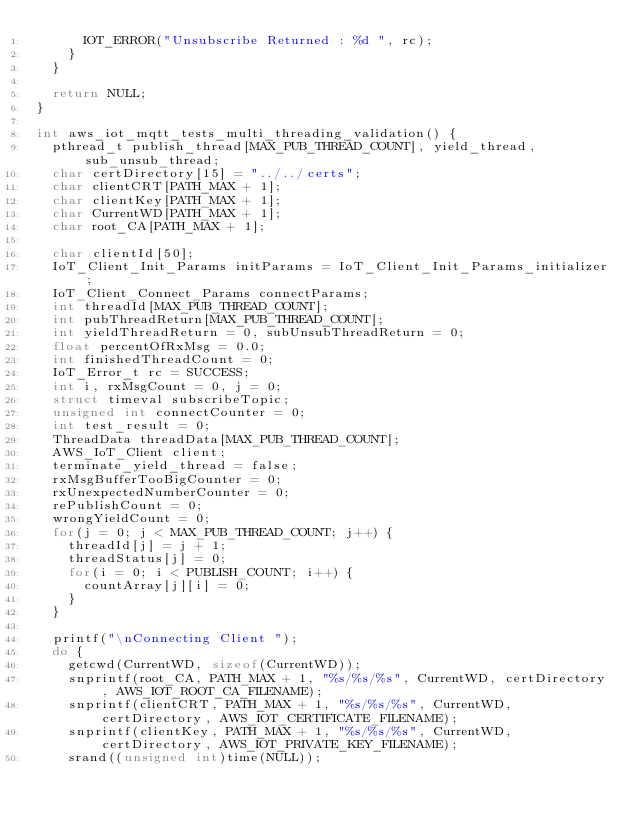<code> <loc_0><loc_0><loc_500><loc_500><_C_>			IOT_ERROR("Unsubscribe Returned : %d ", rc);
		}
	}

	return NULL;
}

int aws_iot_mqtt_tests_multi_threading_validation() {
	pthread_t publish_thread[MAX_PUB_THREAD_COUNT], yield_thread, sub_unsub_thread;
	char certDirectory[15] = "../../certs";
	char clientCRT[PATH_MAX + 1];
	char clientKey[PATH_MAX + 1];
	char CurrentWD[PATH_MAX + 1];
	char root_CA[PATH_MAX + 1];

	char clientId[50];
	IoT_Client_Init_Params initParams = IoT_Client_Init_Params_initializer;
	IoT_Client_Connect_Params connectParams;
	int threadId[MAX_PUB_THREAD_COUNT];
	int pubThreadReturn[MAX_PUB_THREAD_COUNT];
	int yieldThreadReturn = 0, subUnsubThreadReturn = 0;
	float percentOfRxMsg = 0.0;
	int finishedThreadCount = 0;
	IoT_Error_t rc = SUCCESS;
	int i, rxMsgCount = 0, j = 0;
	struct timeval subscribeTopic;
	unsigned int connectCounter = 0;
	int test_result = 0;
	ThreadData threadData[MAX_PUB_THREAD_COUNT];
	AWS_IoT_Client client;
	terminate_yield_thread = false;
	rxMsgBufferTooBigCounter = 0;
	rxUnexpectedNumberCounter = 0;
	rePublishCount = 0;
	wrongYieldCount = 0;
	for(j = 0; j < MAX_PUB_THREAD_COUNT; j++) {
		threadId[j] = j + 1;
		threadStatus[j] = 0;
		for(i = 0; i < PUBLISH_COUNT; i++) {
			countArray[j][i] = 0;
		}
	}

	printf("\nConnecting Client ");
	do {
		getcwd(CurrentWD, sizeof(CurrentWD));
		snprintf(root_CA, PATH_MAX + 1, "%s/%s/%s", CurrentWD, certDirectory, AWS_IOT_ROOT_CA_FILENAME);
		snprintf(clientCRT, PATH_MAX + 1, "%s/%s/%s", CurrentWD, certDirectory, AWS_IOT_CERTIFICATE_FILENAME);
		snprintf(clientKey, PATH_MAX + 1, "%s/%s/%s", CurrentWD, certDirectory, AWS_IOT_PRIVATE_KEY_FILENAME);
		srand((unsigned int)time(NULL));</code> 